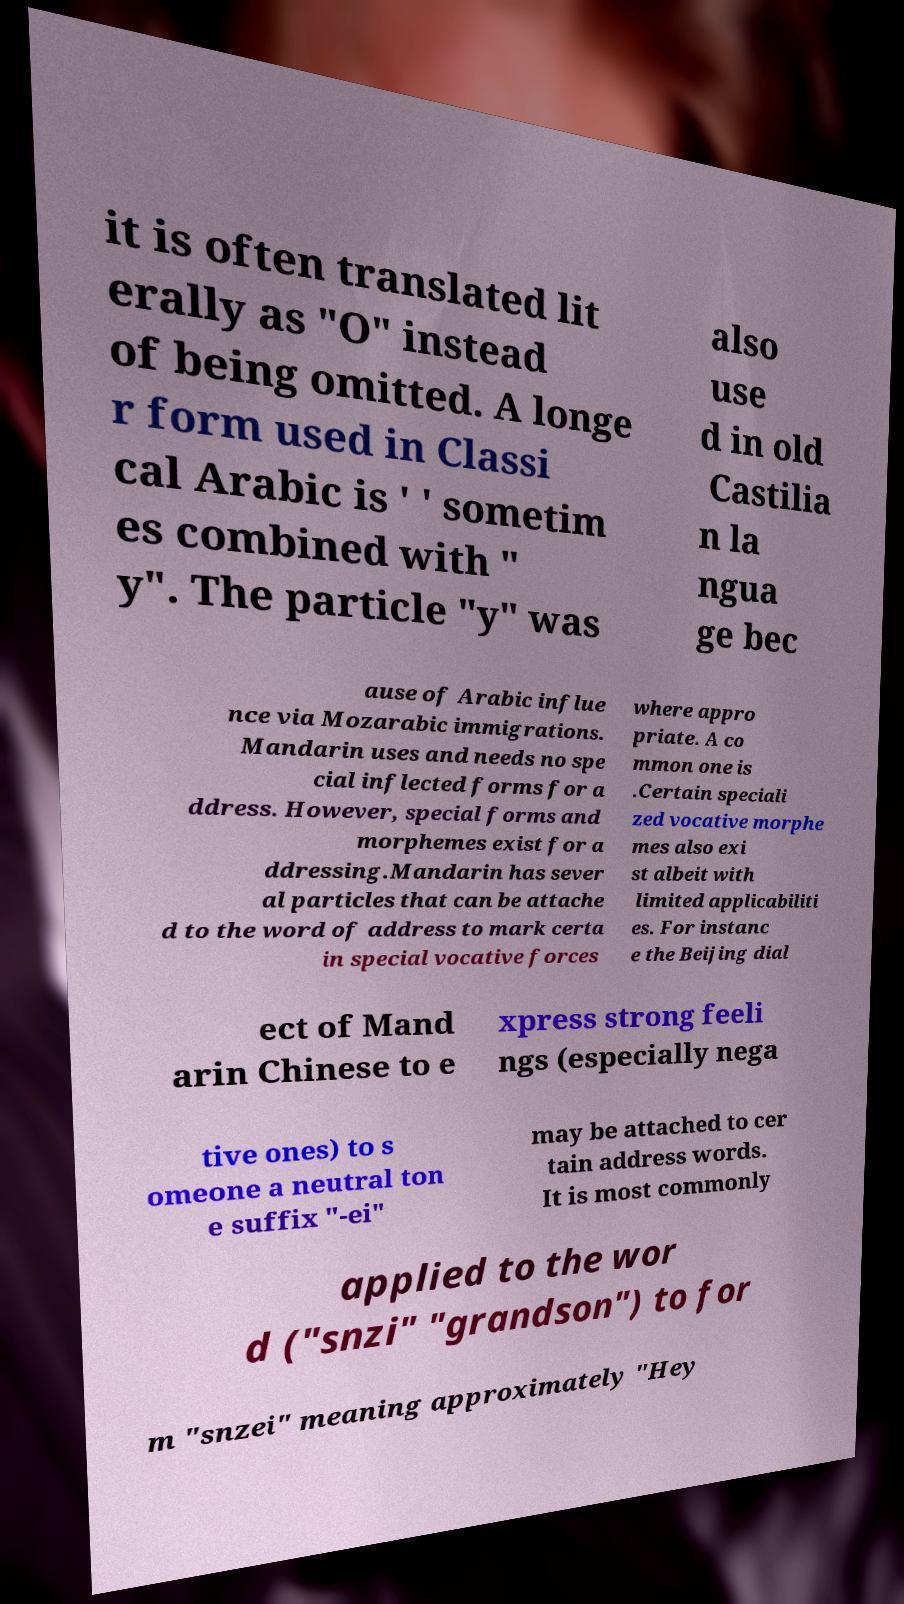Please identify and transcribe the text found in this image. it is often translated lit erally as "O" instead of being omitted. A longe r form used in Classi cal Arabic is ' ' sometim es combined with " y". The particle "y" was also use d in old Castilia n la ngua ge bec ause of Arabic influe nce via Mozarabic immigrations. Mandarin uses and needs no spe cial inflected forms for a ddress. However, special forms and morphemes exist for a ddressing.Mandarin has sever al particles that can be attache d to the word of address to mark certa in special vocative forces where appro priate. A co mmon one is .Certain speciali zed vocative morphe mes also exi st albeit with limited applicabiliti es. For instanc e the Beijing dial ect of Mand arin Chinese to e xpress strong feeli ngs (especially nega tive ones) to s omeone a neutral ton e suffix "-ei" may be attached to cer tain address words. It is most commonly applied to the wor d ("snzi" "grandson") to for m "snzei" meaning approximately "Hey 